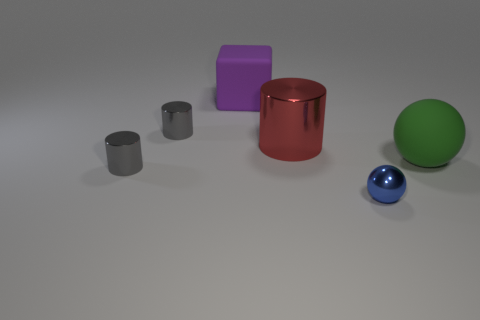There is a tiny thing behind the large matte ball; is it the same color as the shiny cylinder that is in front of the red thing?
Offer a terse response. Yes. There is a matte thing in front of the red metal object; are there any small metal cylinders behind it?
Your answer should be compact. Yes. How many things are both on the right side of the small blue sphere and left of the purple thing?
Provide a short and direct response. 0. What number of large purple things are the same material as the big green thing?
Your answer should be compact. 1. What is the size of the cylinder that is in front of the big thing right of the large cylinder?
Give a very brief answer. Small. Are there any other things that have the same shape as the big red metal thing?
Provide a succinct answer. Yes. Do the thing that is on the right side of the small shiny sphere and the blue thing that is right of the purple object have the same size?
Your answer should be compact. No. Is the number of blue shiny balls behind the blue metallic thing less than the number of spheres in front of the large green ball?
Offer a terse response. Yes. There is a metal cylinder on the right side of the cube; what color is it?
Your response must be concise. Red. How many things are in front of the cylinder on the left side of the tiny gray shiny cylinder behind the green object?
Offer a very short reply. 1. 